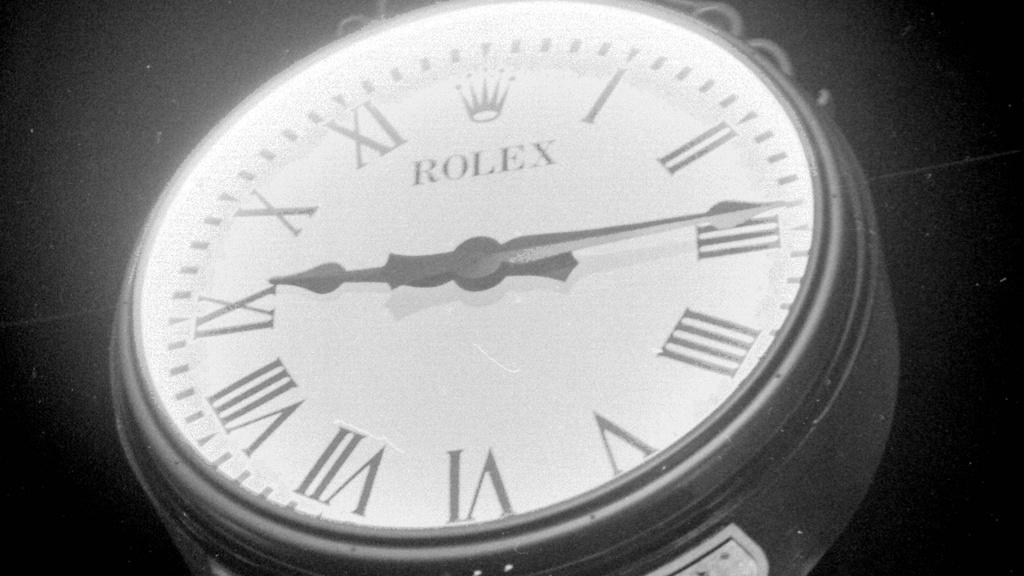<image>
Describe the image concisely. A white clock shows the time as "9:15." 